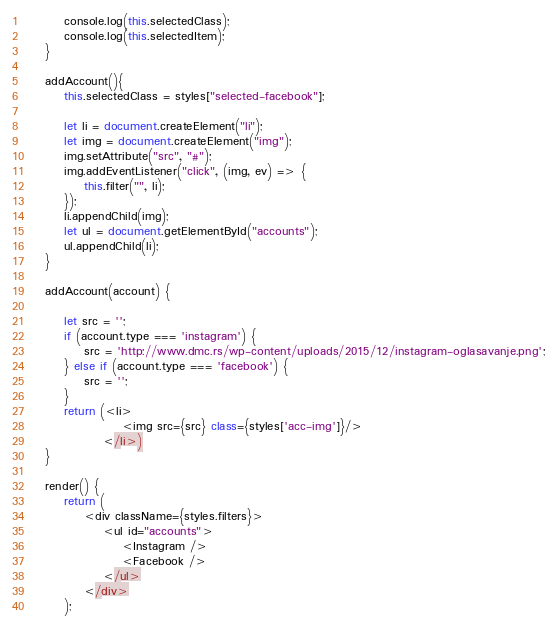<code> <loc_0><loc_0><loc_500><loc_500><_JavaScript_>        console.log(this.selectedClass);
        console.log(this.selectedItem);
    }

    addAccount(){
        this.selectedClass = styles["selected-facebook"];

        let li = document.createElement("li");
        let img = document.createElement("img");
        img.setAttribute("src", "#");
        img.addEventListener("click", (img, ev) => {
            this.filter("", li);
        });
        li.appendChild(img);
        let ul = document.getElementById("accounts");
        ul.appendChild(li);
    }

    addAccount(account) {
        
        let src = '';
        if (account.type === 'instagram') {
            src = 'http://www.dmc.rs/wp-content/uploads/2015/12/instagram-oglasavanje.png';
        } else if (account.type === 'facebook') {
            src = '';
        }
        return (<li>
                    <img src={src} class={styles['acc-img']}/>
                </li>)
    }

    render() {
        return (
            <div className={styles.filters}>
                <ul id="accounts">
                    <Instagram />
                    <Facebook />
                </ul>
            </div>
        );</code> 